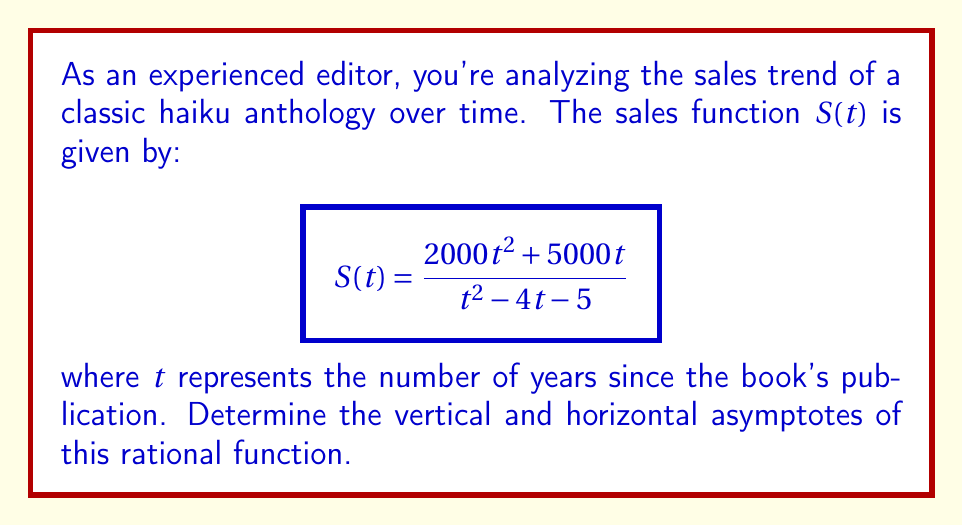Help me with this question. To find the asymptotes of this rational function, we'll follow these steps:

1. Vertical asymptotes:
   Set the denominator to zero and solve for t:
   $t^2 - 4t - 5 = 0$
   $(t - 5)(t + 1) = 0$
   $t = 5$ or $t = -1$
   
   The vertical asymptotes occur at $t = 5$ and $t = -1$. However, since time cannot be negative in this context, we only consider $t = 5$ as a relevant vertical asymptote.

2. Horizontal asymptote:
   Compare the degrees of the numerator and denominator:
   Numerator degree: 2
   Denominator degree: 2
   
   Since the degrees are equal, the horizontal asymptote is the ratio of the leading coefficients:
   
   $$\lim_{t \to \infty} \frac{2000t^2 + 5000t}{t^2 - 4t - 5} = \frac{2000}{1} = 2000$$

Therefore, the horizontal asymptote is $y = 2000$.

3. Slant asymptote:
   There is no slant asymptote in this case because the degrees of the numerator and denominator are equal.
Answer: Vertical asymptote: $t = 5$; Horizontal asymptote: $y = 2000$ 